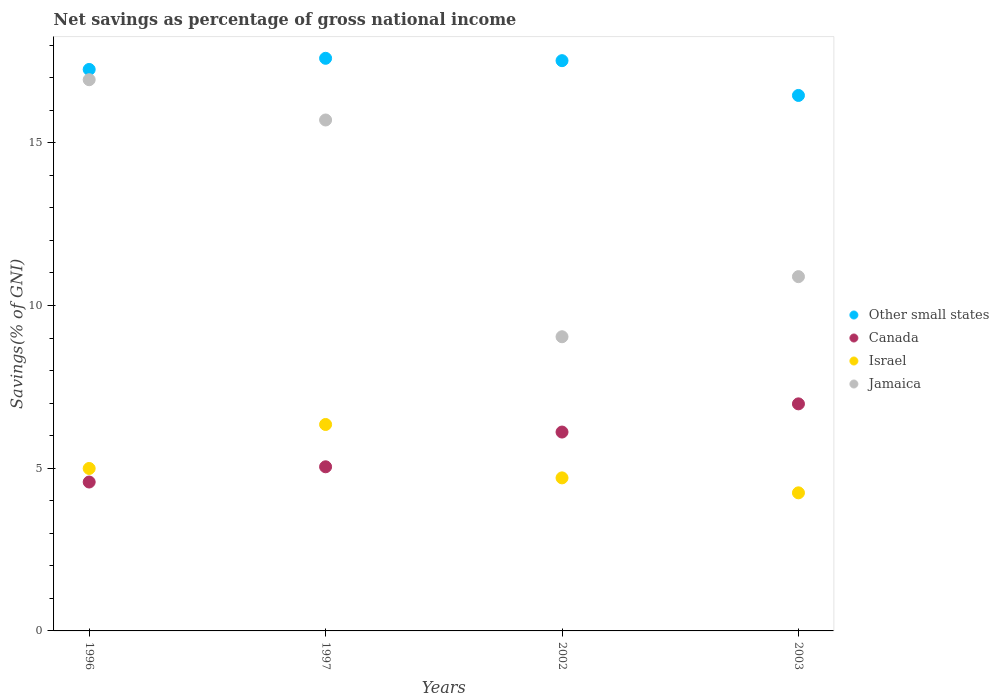How many different coloured dotlines are there?
Your answer should be very brief. 4. What is the total savings in Jamaica in 2003?
Your answer should be very brief. 10.89. Across all years, what is the maximum total savings in Jamaica?
Your response must be concise. 16.94. Across all years, what is the minimum total savings in Other small states?
Offer a terse response. 16.45. In which year was the total savings in Canada minimum?
Your response must be concise. 1996. What is the total total savings in Canada in the graph?
Ensure brevity in your answer.  22.71. What is the difference between the total savings in Israel in 2002 and that in 2003?
Your response must be concise. 0.46. What is the difference between the total savings in Jamaica in 1997 and the total savings in Israel in 1996?
Your answer should be very brief. 10.71. What is the average total savings in Other small states per year?
Offer a very short reply. 17.21. In the year 1996, what is the difference between the total savings in Jamaica and total savings in Israel?
Provide a succinct answer. 11.95. In how many years, is the total savings in Jamaica greater than 6 %?
Ensure brevity in your answer.  4. What is the ratio of the total savings in Jamaica in 1997 to that in 2002?
Provide a succinct answer. 1.74. Is the difference between the total savings in Jamaica in 2002 and 2003 greater than the difference between the total savings in Israel in 2002 and 2003?
Make the answer very short. No. What is the difference between the highest and the second highest total savings in Israel?
Ensure brevity in your answer.  1.35. What is the difference between the highest and the lowest total savings in Canada?
Provide a succinct answer. 2.4. In how many years, is the total savings in Israel greater than the average total savings in Israel taken over all years?
Make the answer very short. 1. Is it the case that in every year, the sum of the total savings in Other small states and total savings in Israel  is greater than the sum of total savings in Canada and total savings in Jamaica?
Make the answer very short. Yes. Is it the case that in every year, the sum of the total savings in Israel and total savings in Jamaica  is greater than the total savings in Canada?
Keep it short and to the point. Yes. Does the total savings in Jamaica monotonically increase over the years?
Give a very brief answer. No. Is the total savings in Jamaica strictly greater than the total savings in Israel over the years?
Keep it short and to the point. Yes. Is the total savings in Canada strictly less than the total savings in Other small states over the years?
Provide a succinct answer. Yes. How many dotlines are there?
Your answer should be very brief. 4. How many years are there in the graph?
Give a very brief answer. 4. What is the difference between two consecutive major ticks on the Y-axis?
Your answer should be very brief. 5. Are the values on the major ticks of Y-axis written in scientific E-notation?
Keep it short and to the point. No. Does the graph contain grids?
Ensure brevity in your answer.  No. Where does the legend appear in the graph?
Ensure brevity in your answer.  Center right. What is the title of the graph?
Ensure brevity in your answer.  Net savings as percentage of gross national income. What is the label or title of the X-axis?
Give a very brief answer. Years. What is the label or title of the Y-axis?
Provide a short and direct response. Savings(% of GNI). What is the Savings(% of GNI) in Other small states in 1996?
Provide a short and direct response. 17.25. What is the Savings(% of GNI) in Canada in 1996?
Offer a very short reply. 4.58. What is the Savings(% of GNI) of Israel in 1996?
Offer a terse response. 4.99. What is the Savings(% of GNI) of Jamaica in 1996?
Provide a succinct answer. 16.94. What is the Savings(% of GNI) of Other small states in 1997?
Keep it short and to the point. 17.6. What is the Savings(% of GNI) of Canada in 1997?
Make the answer very short. 5.04. What is the Savings(% of GNI) in Israel in 1997?
Offer a very short reply. 6.34. What is the Savings(% of GNI) of Jamaica in 1997?
Provide a succinct answer. 15.7. What is the Savings(% of GNI) in Other small states in 2002?
Give a very brief answer. 17.52. What is the Savings(% of GNI) of Canada in 2002?
Your answer should be compact. 6.11. What is the Savings(% of GNI) of Israel in 2002?
Your response must be concise. 4.7. What is the Savings(% of GNI) of Jamaica in 2002?
Ensure brevity in your answer.  9.04. What is the Savings(% of GNI) of Other small states in 2003?
Your answer should be compact. 16.45. What is the Savings(% of GNI) in Canada in 2003?
Ensure brevity in your answer.  6.98. What is the Savings(% of GNI) of Israel in 2003?
Ensure brevity in your answer.  4.24. What is the Savings(% of GNI) of Jamaica in 2003?
Offer a very short reply. 10.89. Across all years, what is the maximum Savings(% of GNI) in Other small states?
Offer a terse response. 17.6. Across all years, what is the maximum Savings(% of GNI) of Canada?
Give a very brief answer. 6.98. Across all years, what is the maximum Savings(% of GNI) in Israel?
Provide a succinct answer. 6.34. Across all years, what is the maximum Savings(% of GNI) in Jamaica?
Provide a short and direct response. 16.94. Across all years, what is the minimum Savings(% of GNI) of Other small states?
Provide a succinct answer. 16.45. Across all years, what is the minimum Savings(% of GNI) of Canada?
Offer a terse response. 4.58. Across all years, what is the minimum Savings(% of GNI) in Israel?
Your response must be concise. 4.24. Across all years, what is the minimum Savings(% of GNI) in Jamaica?
Ensure brevity in your answer.  9.04. What is the total Savings(% of GNI) in Other small states in the graph?
Keep it short and to the point. 68.83. What is the total Savings(% of GNI) of Canada in the graph?
Give a very brief answer. 22.71. What is the total Savings(% of GNI) in Israel in the graph?
Your answer should be very brief. 20.28. What is the total Savings(% of GNI) of Jamaica in the graph?
Give a very brief answer. 52.56. What is the difference between the Savings(% of GNI) of Other small states in 1996 and that in 1997?
Your response must be concise. -0.34. What is the difference between the Savings(% of GNI) in Canada in 1996 and that in 1997?
Keep it short and to the point. -0.47. What is the difference between the Savings(% of GNI) in Israel in 1996 and that in 1997?
Make the answer very short. -1.35. What is the difference between the Savings(% of GNI) of Jamaica in 1996 and that in 1997?
Your answer should be very brief. 1.24. What is the difference between the Savings(% of GNI) of Other small states in 1996 and that in 2002?
Give a very brief answer. -0.27. What is the difference between the Savings(% of GNI) of Canada in 1996 and that in 2002?
Provide a succinct answer. -1.54. What is the difference between the Savings(% of GNI) in Israel in 1996 and that in 2002?
Your response must be concise. 0.29. What is the difference between the Savings(% of GNI) of Jamaica in 1996 and that in 2002?
Provide a short and direct response. 7.9. What is the difference between the Savings(% of GNI) of Other small states in 1996 and that in 2003?
Your response must be concise. 0.8. What is the difference between the Savings(% of GNI) in Canada in 1996 and that in 2003?
Make the answer very short. -2.4. What is the difference between the Savings(% of GNI) of Israel in 1996 and that in 2003?
Keep it short and to the point. 0.75. What is the difference between the Savings(% of GNI) of Jamaica in 1996 and that in 2003?
Offer a very short reply. 6.05. What is the difference between the Savings(% of GNI) of Other small states in 1997 and that in 2002?
Your response must be concise. 0.07. What is the difference between the Savings(% of GNI) of Canada in 1997 and that in 2002?
Ensure brevity in your answer.  -1.07. What is the difference between the Savings(% of GNI) in Israel in 1997 and that in 2002?
Your answer should be compact. 1.64. What is the difference between the Savings(% of GNI) in Jamaica in 1997 and that in 2002?
Your response must be concise. 6.66. What is the difference between the Savings(% of GNI) in Other small states in 1997 and that in 2003?
Your response must be concise. 1.14. What is the difference between the Savings(% of GNI) of Canada in 1997 and that in 2003?
Ensure brevity in your answer.  -1.93. What is the difference between the Savings(% of GNI) in Israel in 1997 and that in 2003?
Keep it short and to the point. 2.1. What is the difference between the Savings(% of GNI) of Jamaica in 1997 and that in 2003?
Your answer should be very brief. 4.81. What is the difference between the Savings(% of GNI) of Other small states in 2002 and that in 2003?
Provide a short and direct response. 1.07. What is the difference between the Savings(% of GNI) in Canada in 2002 and that in 2003?
Make the answer very short. -0.87. What is the difference between the Savings(% of GNI) of Israel in 2002 and that in 2003?
Make the answer very short. 0.46. What is the difference between the Savings(% of GNI) of Jamaica in 2002 and that in 2003?
Provide a short and direct response. -1.85. What is the difference between the Savings(% of GNI) in Other small states in 1996 and the Savings(% of GNI) in Canada in 1997?
Your answer should be very brief. 12.21. What is the difference between the Savings(% of GNI) of Other small states in 1996 and the Savings(% of GNI) of Israel in 1997?
Provide a short and direct response. 10.91. What is the difference between the Savings(% of GNI) of Other small states in 1996 and the Savings(% of GNI) of Jamaica in 1997?
Make the answer very short. 1.55. What is the difference between the Savings(% of GNI) in Canada in 1996 and the Savings(% of GNI) in Israel in 1997?
Provide a succinct answer. -1.77. What is the difference between the Savings(% of GNI) in Canada in 1996 and the Savings(% of GNI) in Jamaica in 1997?
Your response must be concise. -11.12. What is the difference between the Savings(% of GNI) in Israel in 1996 and the Savings(% of GNI) in Jamaica in 1997?
Ensure brevity in your answer.  -10.71. What is the difference between the Savings(% of GNI) in Other small states in 1996 and the Savings(% of GNI) in Canada in 2002?
Give a very brief answer. 11.14. What is the difference between the Savings(% of GNI) of Other small states in 1996 and the Savings(% of GNI) of Israel in 2002?
Your response must be concise. 12.55. What is the difference between the Savings(% of GNI) of Other small states in 1996 and the Savings(% of GNI) of Jamaica in 2002?
Your answer should be compact. 8.21. What is the difference between the Savings(% of GNI) of Canada in 1996 and the Savings(% of GNI) of Israel in 2002?
Your response must be concise. -0.13. What is the difference between the Savings(% of GNI) of Canada in 1996 and the Savings(% of GNI) of Jamaica in 2002?
Give a very brief answer. -4.46. What is the difference between the Savings(% of GNI) of Israel in 1996 and the Savings(% of GNI) of Jamaica in 2002?
Provide a short and direct response. -4.05. What is the difference between the Savings(% of GNI) of Other small states in 1996 and the Savings(% of GNI) of Canada in 2003?
Offer a very short reply. 10.28. What is the difference between the Savings(% of GNI) in Other small states in 1996 and the Savings(% of GNI) in Israel in 2003?
Offer a terse response. 13.01. What is the difference between the Savings(% of GNI) of Other small states in 1996 and the Savings(% of GNI) of Jamaica in 2003?
Provide a succinct answer. 6.37. What is the difference between the Savings(% of GNI) in Canada in 1996 and the Savings(% of GNI) in Israel in 2003?
Keep it short and to the point. 0.33. What is the difference between the Savings(% of GNI) in Canada in 1996 and the Savings(% of GNI) in Jamaica in 2003?
Keep it short and to the point. -6.31. What is the difference between the Savings(% of GNI) of Israel in 1996 and the Savings(% of GNI) of Jamaica in 2003?
Offer a terse response. -5.89. What is the difference between the Savings(% of GNI) of Other small states in 1997 and the Savings(% of GNI) of Canada in 2002?
Ensure brevity in your answer.  11.48. What is the difference between the Savings(% of GNI) of Other small states in 1997 and the Savings(% of GNI) of Israel in 2002?
Ensure brevity in your answer.  12.89. What is the difference between the Savings(% of GNI) of Other small states in 1997 and the Savings(% of GNI) of Jamaica in 2002?
Ensure brevity in your answer.  8.56. What is the difference between the Savings(% of GNI) in Canada in 1997 and the Savings(% of GNI) in Israel in 2002?
Offer a terse response. 0.34. What is the difference between the Savings(% of GNI) of Canada in 1997 and the Savings(% of GNI) of Jamaica in 2002?
Ensure brevity in your answer.  -4. What is the difference between the Savings(% of GNI) of Israel in 1997 and the Savings(% of GNI) of Jamaica in 2002?
Your response must be concise. -2.7. What is the difference between the Savings(% of GNI) of Other small states in 1997 and the Savings(% of GNI) of Canada in 2003?
Your response must be concise. 10.62. What is the difference between the Savings(% of GNI) in Other small states in 1997 and the Savings(% of GNI) in Israel in 2003?
Provide a short and direct response. 13.35. What is the difference between the Savings(% of GNI) of Other small states in 1997 and the Savings(% of GNI) of Jamaica in 2003?
Your response must be concise. 6.71. What is the difference between the Savings(% of GNI) of Canada in 1997 and the Savings(% of GNI) of Israel in 2003?
Provide a succinct answer. 0.8. What is the difference between the Savings(% of GNI) in Canada in 1997 and the Savings(% of GNI) in Jamaica in 2003?
Provide a succinct answer. -5.84. What is the difference between the Savings(% of GNI) of Israel in 1997 and the Savings(% of GNI) of Jamaica in 2003?
Make the answer very short. -4.54. What is the difference between the Savings(% of GNI) in Other small states in 2002 and the Savings(% of GNI) in Canada in 2003?
Your answer should be compact. 10.55. What is the difference between the Savings(% of GNI) of Other small states in 2002 and the Savings(% of GNI) of Israel in 2003?
Give a very brief answer. 13.28. What is the difference between the Savings(% of GNI) of Other small states in 2002 and the Savings(% of GNI) of Jamaica in 2003?
Your answer should be very brief. 6.64. What is the difference between the Savings(% of GNI) of Canada in 2002 and the Savings(% of GNI) of Israel in 2003?
Ensure brevity in your answer.  1.87. What is the difference between the Savings(% of GNI) of Canada in 2002 and the Savings(% of GNI) of Jamaica in 2003?
Your answer should be very brief. -4.78. What is the difference between the Savings(% of GNI) in Israel in 2002 and the Savings(% of GNI) in Jamaica in 2003?
Offer a very short reply. -6.18. What is the average Savings(% of GNI) of Other small states per year?
Keep it short and to the point. 17.21. What is the average Savings(% of GNI) of Canada per year?
Your response must be concise. 5.68. What is the average Savings(% of GNI) in Israel per year?
Your response must be concise. 5.07. What is the average Savings(% of GNI) in Jamaica per year?
Your response must be concise. 13.14. In the year 1996, what is the difference between the Savings(% of GNI) of Other small states and Savings(% of GNI) of Canada?
Offer a very short reply. 12.68. In the year 1996, what is the difference between the Savings(% of GNI) in Other small states and Savings(% of GNI) in Israel?
Your answer should be compact. 12.26. In the year 1996, what is the difference between the Savings(% of GNI) of Other small states and Savings(% of GNI) of Jamaica?
Keep it short and to the point. 0.32. In the year 1996, what is the difference between the Savings(% of GNI) of Canada and Savings(% of GNI) of Israel?
Your answer should be compact. -0.42. In the year 1996, what is the difference between the Savings(% of GNI) in Canada and Savings(% of GNI) in Jamaica?
Keep it short and to the point. -12.36. In the year 1996, what is the difference between the Savings(% of GNI) in Israel and Savings(% of GNI) in Jamaica?
Offer a very short reply. -11.95. In the year 1997, what is the difference between the Savings(% of GNI) of Other small states and Savings(% of GNI) of Canada?
Provide a short and direct response. 12.55. In the year 1997, what is the difference between the Savings(% of GNI) of Other small states and Savings(% of GNI) of Israel?
Ensure brevity in your answer.  11.25. In the year 1997, what is the difference between the Savings(% of GNI) in Other small states and Savings(% of GNI) in Jamaica?
Your response must be concise. 1.9. In the year 1997, what is the difference between the Savings(% of GNI) of Canada and Savings(% of GNI) of Israel?
Your response must be concise. -1.3. In the year 1997, what is the difference between the Savings(% of GNI) in Canada and Savings(% of GNI) in Jamaica?
Offer a very short reply. -10.66. In the year 1997, what is the difference between the Savings(% of GNI) of Israel and Savings(% of GNI) of Jamaica?
Provide a short and direct response. -9.36. In the year 2002, what is the difference between the Savings(% of GNI) in Other small states and Savings(% of GNI) in Canada?
Your answer should be very brief. 11.41. In the year 2002, what is the difference between the Savings(% of GNI) in Other small states and Savings(% of GNI) in Israel?
Offer a very short reply. 12.82. In the year 2002, what is the difference between the Savings(% of GNI) of Other small states and Savings(% of GNI) of Jamaica?
Make the answer very short. 8.48. In the year 2002, what is the difference between the Savings(% of GNI) in Canada and Savings(% of GNI) in Israel?
Keep it short and to the point. 1.41. In the year 2002, what is the difference between the Savings(% of GNI) in Canada and Savings(% of GNI) in Jamaica?
Your response must be concise. -2.93. In the year 2002, what is the difference between the Savings(% of GNI) in Israel and Savings(% of GNI) in Jamaica?
Provide a succinct answer. -4.34. In the year 2003, what is the difference between the Savings(% of GNI) in Other small states and Savings(% of GNI) in Canada?
Ensure brevity in your answer.  9.48. In the year 2003, what is the difference between the Savings(% of GNI) of Other small states and Savings(% of GNI) of Israel?
Ensure brevity in your answer.  12.21. In the year 2003, what is the difference between the Savings(% of GNI) of Other small states and Savings(% of GNI) of Jamaica?
Keep it short and to the point. 5.57. In the year 2003, what is the difference between the Savings(% of GNI) in Canada and Savings(% of GNI) in Israel?
Provide a short and direct response. 2.73. In the year 2003, what is the difference between the Savings(% of GNI) of Canada and Savings(% of GNI) of Jamaica?
Offer a terse response. -3.91. In the year 2003, what is the difference between the Savings(% of GNI) in Israel and Savings(% of GNI) in Jamaica?
Ensure brevity in your answer.  -6.64. What is the ratio of the Savings(% of GNI) in Other small states in 1996 to that in 1997?
Keep it short and to the point. 0.98. What is the ratio of the Savings(% of GNI) in Canada in 1996 to that in 1997?
Give a very brief answer. 0.91. What is the ratio of the Savings(% of GNI) in Israel in 1996 to that in 1997?
Provide a short and direct response. 0.79. What is the ratio of the Savings(% of GNI) of Jamaica in 1996 to that in 1997?
Your answer should be very brief. 1.08. What is the ratio of the Savings(% of GNI) in Other small states in 1996 to that in 2002?
Provide a short and direct response. 0.98. What is the ratio of the Savings(% of GNI) in Canada in 1996 to that in 2002?
Provide a succinct answer. 0.75. What is the ratio of the Savings(% of GNI) in Israel in 1996 to that in 2002?
Provide a succinct answer. 1.06. What is the ratio of the Savings(% of GNI) of Jamaica in 1996 to that in 2002?
Your answer should be compact. 1.87. What is the ratio of the Savings(% of GNI) in Other small states in 1996 to that in 2003?
Provide a succinct answer. 1.05. What is the ratio of the Savings(% of GNI) in Canada in 1996 to that in 2003?
Offer a terse response. 0.66. What is the ratio of the Savings(% of GNI) of Israel in 1996 to that in 2003?
Ensure brevity in your answer.  1.18. What is the ratio of the Savings(% of GNI) of Jamaica in 1996 to that in 2003?
Keep it short and to the point. 1.56. What is the ratio of the Savings(% of GNI) of Other small states in 1997 to that in 2002?
Offer a terse response. 1. What is the ratio of the Savings(% of GNI) in Canada in 1997 to that in 2002?
Offer a terse response. 0.83. What is the ratio of the Savings(% of GNI) of Israel in 1997 to that in 2002?
Your answer should be very brief. 1.35. What is the ratio of the Savings(% of GNI) of Jamaica in 1997 to that in 2002?
Your answer should be compact. 1.74. What is the ratio of the Savings(% of GNI) of Other small states in 1997 to that in 2003?
Provide a short and direct response. 1.07. What is the ratio of the Savings(% of GNI) in Canada in 1997 to that in 2003?
Provide a short and direct response. 0.72. What is the ratio of the Savings(% of GNI) in Israel in 1997 to that in 2003?
Your answer should be compact. 1.5. What is the ratio of the Savings(% of GNI) in Jamaica in 1997 to that in 2003?
Ensure brevity in your answer.  1.44. What is the ratio of the Savings(% of GNI) of Other small states in 2002 to that in 2003?
Keep it short and to the point. 1.06. What is the ratio of the Savings(% of GNI) in Canada in 2002 to that in 2003?
Offer a terse response. 0.88. What is the ratio of the Savings(% of GNI) of Israel in 2002 to that in 2003?
Provide a succinct answer. 1.11. What is the ratio of the Savings(% of GNI) of Jamaica in 2002 to that in 2003?
Keep it short and to the point. 0.83. What is the difference between the highest and the second highest Savings(% of GNI) in Other small states?
Offer a very short reply. 0.07. What is the difference between the highest and the second highest Savings(% of GNI) of Canada?
Offer a terse response. 0.87. What is the difference between the highest and the second highest Savings(% of GNI) in Israel?
Ensure brevity in your answer.  1.35. What is the difference between the highest and the second highest Savings(% of GNI) of Jamaica?
Make the answer very short. 1.24. What is the difference between the highest and the lowest Savings(% of GNI) in Other small states?
Your answer should be very brief. 1.14. What is the difference between the highest and the lowest Savings(% of GNI) in Canada?
Ensure brevity in your answer.  2.4. What is the difference between the highest and the lowest Savings(% of GNI) of Israel?
Your response must be concise. 2.1. What is the difference between the highest and the lowest Savings(% of GNI) of Jamaica?
Your answer should be compact. 7.9. 